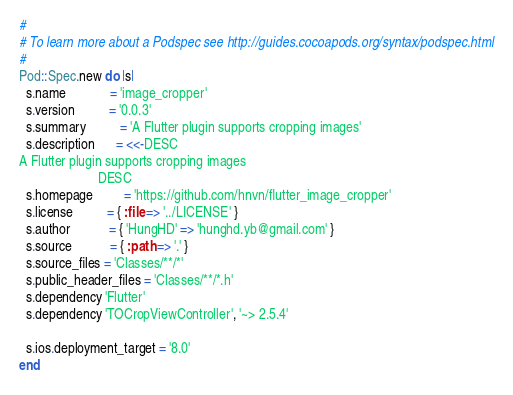<code> <loc_0><loc_0><loc_500><loc_500><_Ruby_>#
# To learn more about a Podspec see http://guides.cocoapods.org/syntax/podspec.html
#
Pod::Spec.new do |s|
  s.name             = 'image_cropper'
  s.version          = '0.0.3'
  s.summary          = 'A Flutter plugin supports cropping images'
  s.description      = <<-DESC
A Flutter plugin supports cropping images
                       DESC
  s.homepage         = 'https://github.com/hnvn/flutter_image_cropper'
  s.license          = { :file => '../LICENSE' }
  s.author           = { 'HungHD' => 'hunghd.yb@gmail.com' }
  s.source           = { :path => '.' }
  s.source_files = 'Classes/**/*'
  s.public_header_files = 'Classes/**/*.h'
  s.dependency 'Flutter'
  s.dependency 'TOCropViewController', '~> 2.5.4'
  
  s.ios.deployment_target = '8.0'
end

</code> 